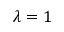<formula> <loc_0><loc_0><loc_500><loc_500>\lambda = 1</formula> 